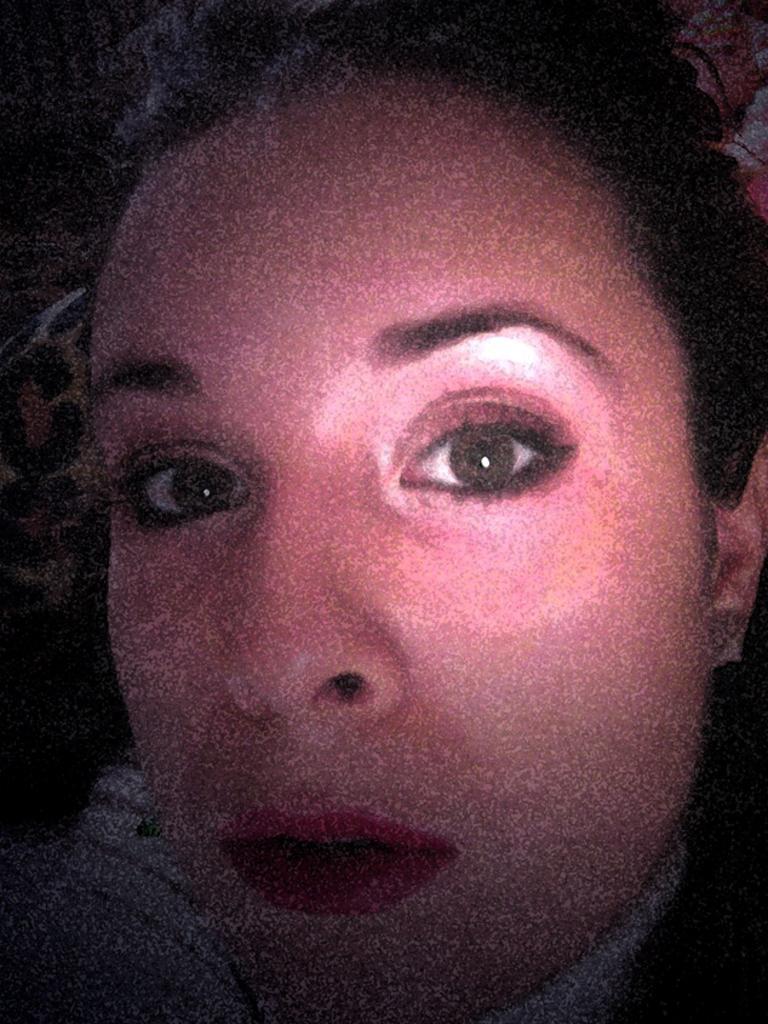Can you describe this image briefly? In this image I can see a person face. 